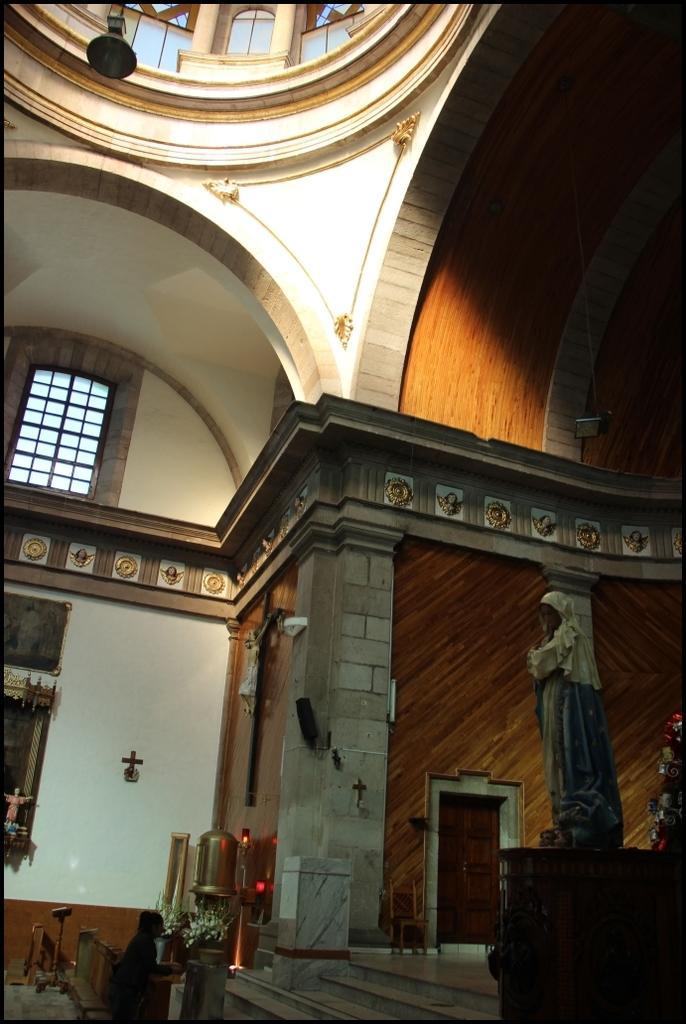How would you summarize this image in a sentence or two? This picture is taken inside the building. In this image, on the right side, we can see a table. On the table, we can see some sculptures. On the left side, we can see some sculptures. In the middle of the image, we can see a person standing in front of the table, on the table, we can see a metal instrument. In the background, we can see a door, wood wall and a wall, window. At the top, we can see a light and a roof. 